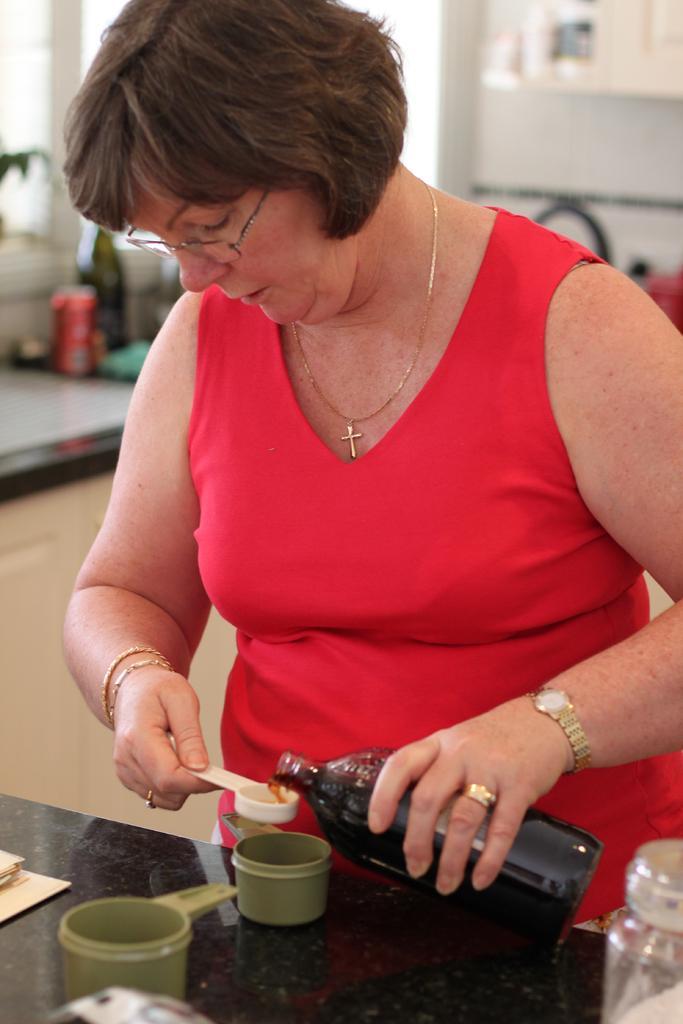Describe this image in one or two sentences. This picture is clicked inside the room. There is woman in red t-shirt holding spoon in one of her hand and on the other hand she is holding glass bottle with some liquid in it. In front of her, we see a table on which phone and jar are placed. Behind her, we see a wall which is white in color and on wall, some white chart is placed on it. 